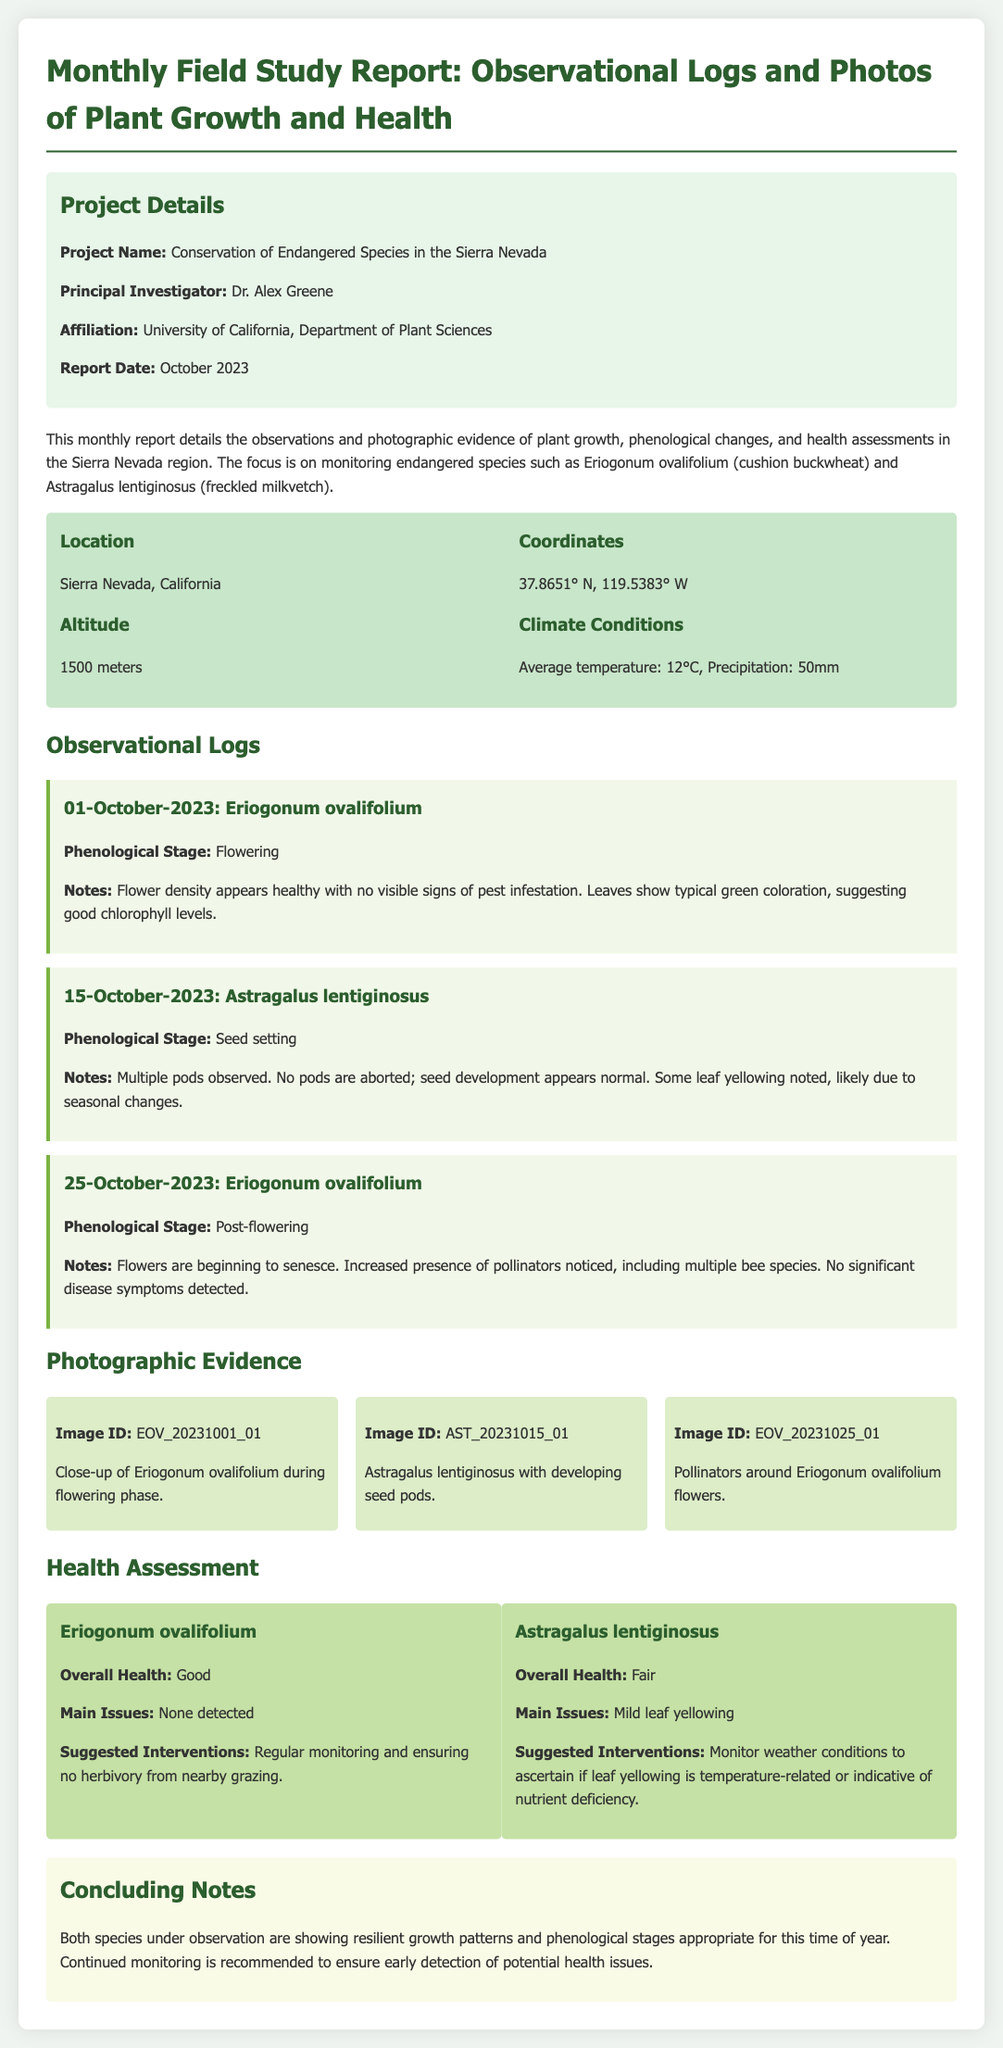what is the project name? The project name is directly stated in the project details section of the document.
Answer: Conservation of Endangered Species in the Sierra Nevada who is the principal investigator? The principal investigator is mentioned in the project details section.
Answer: Dr. Alex Greene what is the report date? The report date is included in the project details section.
Answer: October 2023 what is the overall health of Eriogonum ovalifolium? The overall health is noted in the health assessment section.
Answer: Good how many different log entries are there? The number of log entries can be counted from the observational logs section.
Answer: Three what phenological stage was Eriogonum ovalifolium on 01-October-2023? The phenological stage is described in the log entry for that date.
Answer: Flowering what is the suggested intervention for Astragalus lentiginosus? Suggested interventions can be found in the health assessment section.
Answer: Monitor weather conditions to ascertain if leaf yellowing is temperature-related or indicative of nutrient deficiency how many photo items are listed in the photographic evidence section? The number of photo items can be counted from the photographic evidence section.
Answer: Three 